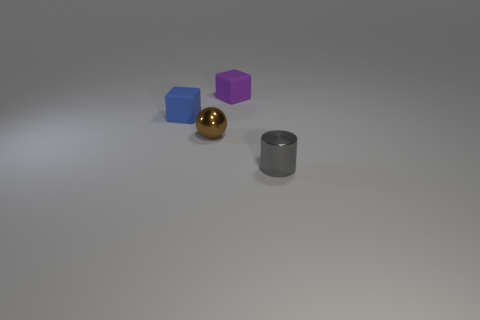There is a small gray cylinder on the right side of the tiny purple matte thing; what is it made of?
Provide a short and direct response. Metal. How many objects are either matte things on the left side of the small purple matte block or large blue rubber cylinders?
Your answer should be very brief. 1. Are there an equal number of blocks on the right side of the small brown thing and tiny green cubes?
Give a very brief answer. No. Do the gray thing and the purple cube have the same size?
Provide a short and direct response. Yes. What is the color of the other cube that is the same size as the blue block?
Your answer should be compact. Purple. There is a purple object; does it have the same size as the matte cube that is to the left of the shiny sphere?
Offer a terse response. Yes. How many matte things are the same color as the metallic cylinder?
Offer a terse response. 0. What number of objects are blue cubes or tiny things that are behind the small blue thing?
Your response must be concise. 2. Do the block that is on the left side of the brown shiny object and the brown ball on the left side of the small purple rubber cube have the same size?
Keep it short and to the point. Yes. Is there a tiny purple object that has the same material as the brown sphere?
Provide a short and direct response. No. 